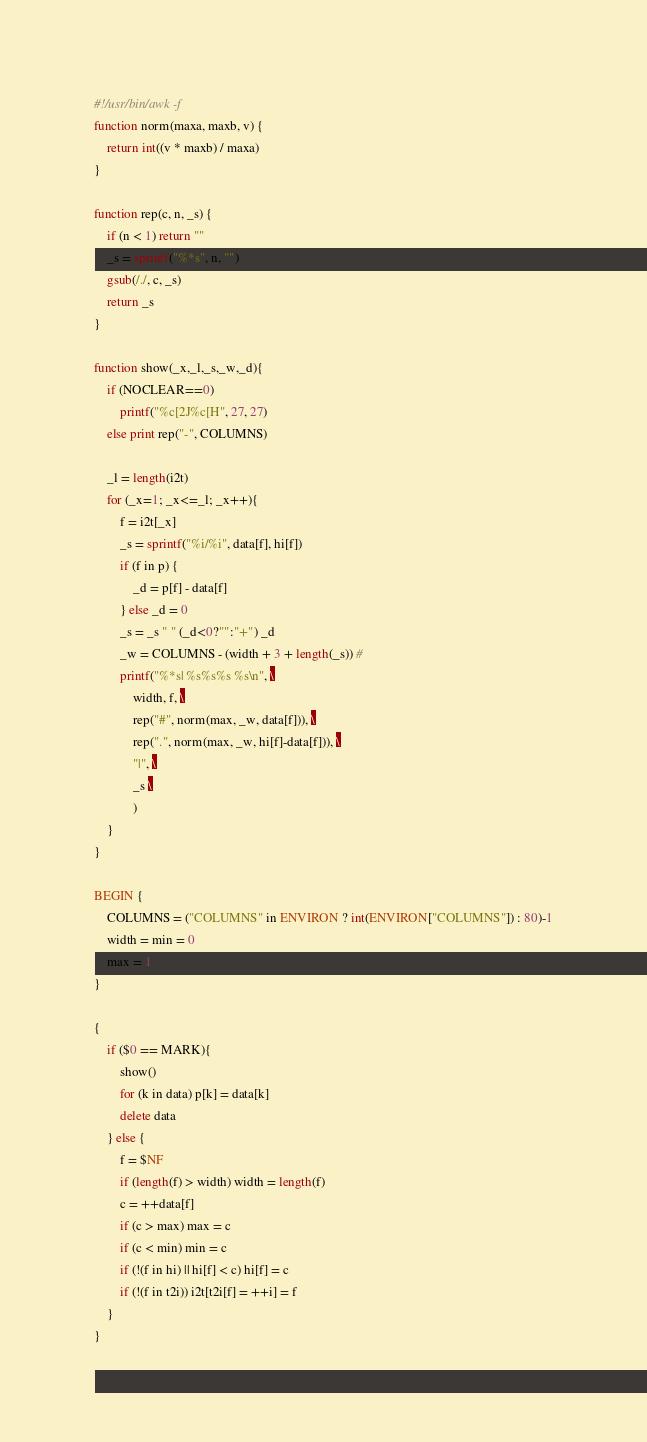Convert code to text. <code><loc_0><loc_0><loc_500><loc_500><_Awk_>#!/usr/bin/awk -f
function norm(maxa, maxb, v) {
    return int((v * maxb) / maxa)
}

function rep(c, n, _s) {
    if (n < 1) return ""
    _s = sprintf("%*s", n, "")
    gsub(/./, c, _s)
    return _s
}

function show(_x,_l,_s,_w,_d){
    if (NOCLEAR==0)
        printf("%c[2J%c[H", 27, 27)
    else print rep("-", COLUMNS)
 
    _l = length(i2t)
    for (_x=1; _x<=_l; _x++){
        f = i2t[_x]
        _s = sprintf("%i/%i", data[f], hi[f])
        if (f in p) {
            _d = p[f] - data[f]
        } else _d = 0
        _s = _s " " (_d<0?"":"+") _d
        _w = COLUMNS - (width + 3 + length(_s)) # 
        printf("%*s| %s%s%s %s\n", \
            width, f, \
            rep("#", norm(max, _w, data[f])), \
            rep(".", norm(max, _w, hi[f]-data[f])), \
            "|", \
            _s \
            )
    }
}

BEGIN {
    COLUMNS = ("COLUMNS" in ENVIRON ? int(ENVIRON["COLUMNS"]) : 80)-1
    width = min = 0
    max = 1
}

{
    if ($0 == MARK){
        show()
        for (k in data) p[k] = data[k]
        delete data
    } else {
        f = $NF
        if (length(f) > width) width = length(f)
        c = ++data[f]
        if (c > max) max = c
        if (c < min) min = c
        if (!(f in hi) || hi[f] < c) hi[f] = c
        if (!(f in t2i)) i2t[t2i[f] = ++i] = f
    }
}
</code> 